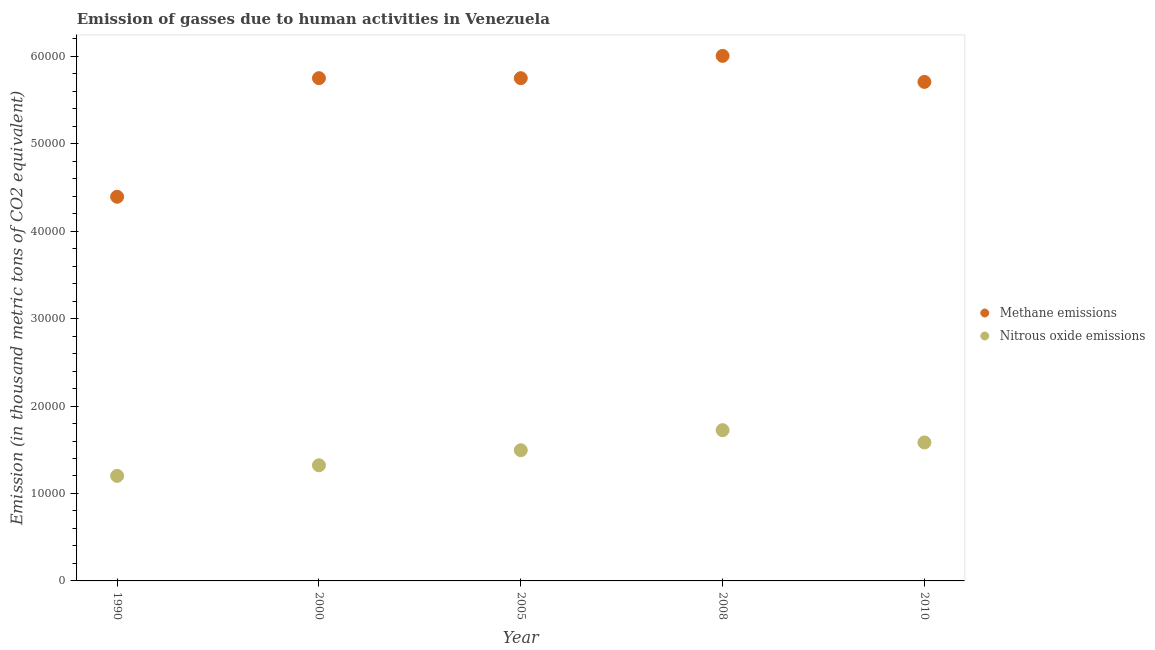What is the amount of methane emissions in 2008?
Ensure brevity in your answer.  6.00e+04. Across all years, what is the maximum amount of nitrous oxide emissions?
Ensure brevity in your answer.  1.72e+04. Across all years, what is the minimum amount of methane emissions?
Your answer should be very brief. 4.39e+04. In which year was the amount of nitrous oxide emissions minimum?
Ensure brevity in your answer.  1990. What is the total amount of methane emissions in the graph?
Make the answer very short. 2.76e+05. What is the difference between the amount of methane emissions in 2008 and that in 2010?
Ensure brevity in your answer.  2976.3. What is the difference between the amount of methane emissions in 2008 and the amount of nitrous oxide emissions in 2005?
Ensure brevity in your answer.  4.51e+04. What is the average amount of methane emissions per year?
Your response must be concise. 5.52e+04. In the year 2008, what is the difference between the amount of nitrous oxide emissions and amount of methane emissions?
Your answer should be compact. -4.28e+04. What is the ratio of the amount of methane emissions in 2000 to that in 2010?
Offer a terse response. 1.01. Is the difference between the amount of methane emissions in 2008 and 2010 greater than the difference between the amount of nitrous oxide emissions in 2008 and 2010?
Your answer should be very brief. Yes. What is the difference between the highest and the second highest amount of nitrous oxide emissions?
Ensure brevity in your answer.  1406.5. What is the difference between the highest and the lowest amount of nitrous oxide emissions?
Provide a succinct answer. 5224.6. In how many years, is the amount of methane emissions greater than the average amount of methane emissions taken over all years?
Keep it short and to the point. 4. Is the sum of the amount of methane emissions in 1990 and 2000 greater than the maximum amount of nitrous oxide emissions across all years?
Keep it short and to the point. Yes. Does the amount of nitrous oxide emissions monotonically increase over the years?
Your answer should be compact. No. How many dotlines are there?
Provide a succinct answer. 2. How many years are there in the graph?
Offer a terse response. 5. What is the difference between two consecutive major ticks on the Y-axis?
Your answer should be very brief. 10000. Are the values on the major ticks of Y-axis written in scientific E-notation?
Your response must be concise. No. Does the graph contain grids?
Your response must be concise. No. Where does the legend appear in the graph?
Keep it short and to the point. Center right. What is the title of the graph?
Ensure brevity in your answer.  Emission of gasses due to human activities in Venezuela. Does "GDP per capita" appear as one of the legend labels in the graph?
Your response must be concise. No. What is the label or title of the X-axis?
Your answer should be very brief. Year. What is the label or title of the Y-axis?
Your response must be concise. Emission (in thousand metric tons of CO2 equivalent). What is the Emission (in thousand metric tons of CO2 equivalent) in Methane emissions in 1990?
Ensure brevity in your answer.  4.39e+04. What is the Emission (in thousand metric tons of CO2 equivalent) of Nitrous oxide emissions in 1990?
Provide a short and direct response. 1.20e+04. What is the Emission (in thousand metric tons of CO2 equivalent) of Methane emissions in 2000?
Give a very brief answer. 5.75e+04. What is the Emission (in thousand metric tons of CO2 equivalent) in Nitrous oxide emissions in 2000?
Ensure brevity in your answer.  1.32e+04. What is the Emission (in thousand metric tons of CO2 equivalent) in Methane emissions in 2005?
Ensure brevity in your answer.  5.75e+04. What is the Emission (in thousand metric tons of CO2 equivalent) in Nitrous oxide emissions in 2005?
Provide a short and direct response. 1.49e+04. What is the Emission (in thousand metric tons of CO2 equivalent) in Methane emissions in 2008?
Your answer should be compact. 6.00e+04. What is the Emission (in thousand metric tons of CO2 equivalent) of Nitrous oxide emissions in 2008?
Your answer should be very brief. 1.72e+04. What is the Emission (in thousand metric tons of CO2 equivalent) of Methane emissions in 2010?
Your answer should be compact. 5.71e+04. What is the Emission (in thousand metric tons of CO2 equivalent) of Nitrous oxide emissions in 2010?
Give a very brief answer. 1.58e+04. Across all years, what is the maximum Emission (in thousand metric tons of CO2 equivalent) of Methane emissions?
Give a very brief answer. 6.00e+04. Across all years, what is the maximum Emission (in thousand metric tons of CO2 equivalent) of Nitrous oxide emissions?
Make the answer very short. 1.72e+04. Across all years, what is the minimum Emission (in thousand metric tons of CO2 equivalent) of Methane emissions?
Your response must be concise. 4.39e+04. Across all years, what is the minimum Emission (in thousand metric tons of CO2 equivalent) of Nitrous oxide emissions?
Make the answer very short. 1.20e+04. What is the total Emission (in thousand metric tons of CO2 equivalent) of Methane emissions in the graph?
Give a very brief answer. 2.76e+05. What is the total Emission (in thousand metric tons of CO2 equivalent) of Nitrous oxide emissions in the graph?
Make the answer very short. 7.33e+04. What is the difference between the Emission (in thousand metric tons of CO2 equivalent) of Methane emissions in 1990 and that in 2000?
Provide a succinct answer. -1.36e+04. What is the difference between the Emission (in thousand metric tons of CO2 equivalent) in Nitrous oxide emissions in 1990 and that in 2000?
Offer a terse response. -1205.8. What is the difference between the Emission (in thousand metric tons of CO2 equivalent) in Methane emissions in 1990 and that in 2005?
Ensure brevity in your answer.  -1.36e+04. What is the difference between the Emission (in thousand metric tons of CO2 equivalent) in Nitrous oxide emissions in 1990 and that in 2005?
Offer a very short reply. -2931.2. What is the difference between the Emission (in thousand metric tons of CO2 equivalent) in Methane emissions in 1990 and that in 2008?
Make the answer very short. -1.61e+04. What is the difference between the Emission (in thousand metric tons of CO2 equivalent) of Nitrous oxide emissions in 1990 and that in 2008?
Give a very brief answer. -5224.6. What is the difference between the Emission (in thousand metric tons of CO2 equivalent) in Methane emissions in 1990 and that in 2010?
Your answer should be very brief. -1.31e+04. What is the difference between the Emission (in thousand metric tons of CO2 equivalent) in Nitrous oxide emissions in 1990 and that in 2010?
Offer a terse response. -3818.1. What is the difference between the Emission (in thousand metric tons of CO2 equivalent) of Nitrous oxide emissions in 2000 and that in 2005?
Provide a succinct answer. -1725.4. What is the difference between the Emission (in thousand metric tons of CO2 equivalent) in Methane emissions in 2000 and that in 2008?
Your response must be concise. -2550.4. What is the difference between the Emission (in thousand metric tons of CO2 equivalent) in Nitrous oxide emissions in 2000 and that in 2008?
Give a very brief answer. -4018.8. What is the difference between the Emission (in thousand metric tons of CO2 equivalent) in Methane emissions in 2000 and that in 2010?
Your answer should be very brief. 425.9. What is the difference between the Emission (in thousand metric tons of CO2 equivalent) of Nitrous oxide emissions in 2000 and that in 2010?
Offer a very short reply. -2612.3. What is the difference between the Emission (in thousand metric tons of CO2 equivalent) of Methane emissions in 2005 and that in 2008?
Give a very brief answer. -2551.2. What is the difference between the Emission (in thousand metric tons of CO2 equivalent) in Nitrous oxide emissions in 2005 and that in 2008?
Make the answer very short. -2293.4. What is the difference between the Emission (in thousand metric tons of CO2 equivalent) of Methane emissions in 2005 and that in 2010?
Keep it short and to the point. 425.1. What is the difference between the Emission (in thousand metric tons of CO2 equivalent) in Nitrous oxide emissions in 2005 and that in 2010?
Offer a terse response. -886.9. What is the difference between the Emission (in thousand metric tons of CO2 equivalent) in Methane emissions in 2008 and that in 2010?
Offer a terse response. 2976.3. What is the difference between the Emission (in thousand metric tons of CO2 equivalent) of Nitrous oxide emissions in 2008 and that in 2010?
Your answer should be compact. 1406.5. What is the difference between the Emission (in thousand metric tons of CO2 equivalent) in Methane emissions in 1990 and the Emission (in thousand metric tons of CO2 equivalent) in Nitrous oxide emissions in 2000?
Make the answer very short. 3.07e+04. What is the difference between the Emission (in thousand metric tons of CO2 equivalent) in Methane emissions in 1990 and the Emission (in thousand metric tons of CO2 equivalent) in Nitrous oxide emissions in 2005?
Provide a succinct answer. 2.90e+04. What is the difference between the Emission (in thousand metric tons of CO2 equivalent) of Methane emissions in 1990 and the Emission (in thousand metric tons of CO2 equivalent) of Nitrous oxide emissions in 2008?
Offer a terse response. 2.67e+04. What is the difference between the Emission (in thousand metric tons of CO2 equivalent) of Methane emissions in 1990 and the Emission (in thousand metric tons of CO2 equivalent) of Nitrous oxide emissions in 2010?
Make the answer very short. 2.81e+04. What is the difference between the Emission (in thousand metric tons of CO2 equivalent) of Methane emissions in 2000 and the Emission (in thousand metric tons of CO2 equivalent) of Nitrous oxide emissions in 2005?
Offer a very short reply. 4.25e+04. What is the difference between the Emission (in thousand metric tons of CO2 equivalent) of Methane emissions in 2000 and the Emission (in thousand metric tons of CO2 equivalent) of Nitrous oxide emissions in 2008?
Your response must be concise. 4.03e+04. What is the difference between the Emission (in thousand metric tons of CO2 equivalent) of Methane emissions in 2000 and the Emission (in thousand metric tons of CO2 equivalent) of Nitrous oxide emissions in 2010?
Give a very brief answer. 4.17e+04. What is the difference between the Emission (in thousand metric tons of CO2 equivalent) in Methane emissions in 2005 and the Emission (in thousand metric tons of CO2 equivalent) in Nitrous oxide emissions in 2008?
Provide a succinct answer. 4.03e+04. What is the difference between the Emission (in thousand metric tons of CO2 equivalent) in Methane emissions in 2005 and the Emission (in thousand metric tons of CO2 equivalent) in Nitrous oxide emissions in 2010?
Make the answer very short. 4.17e+04. What is the difference between the Emission (in thousand metric tons of CO2 equivalent) in Methane emissions in 2008 and the Emission (in thousand metric tons of CO2 equivalent) in Nitrous oxide emissions in 2010?
Your response must be concise. 4.42e+04. What is the average Emission (in thousand metric tons of CO2 equivalent) of Methane emissions per year?
Keep it short and to the point. 5.52e+04. What is the average Emission (in thousand metric tons of CO2 equivalent) of Nitrous oxide emissions per year?
Provide a short and direct response. 1.47e+04. In the year 1990, what is the difference between the Emission (in thousand metric tons of CO2 equivalent) in Methane emissions and Emission (in thousand metric tons of CO2 equivalent) in Nitrous oxide emissions?
Your answer should be compact. 3.19e+04. In the year 2000, what is the difference between the Emission (in thousand metric tons of CO2 equivalent) in Methane emissions and Emission (in thousand metric tons of CO2 equivalent) in Nitrous oxide emissions?
Keep it short and to the point. 4.43e+04. In the year 2005, what is the difference between the Emission (in thousand metric tons of CO2 equivalent) of Methane emissions and Emission (in thousand metric tons of CO2 equivalent) of Nitrous oxide emissions?
Your response must be concise. 4.25e+04. In the year 2008, what is the difference between the Emission (in thousand metric tons of CO2 equivalent) in Methane emissions and Emission (in thousand metric tons of CO2 equivalent) in Nitrous oxide emissions?
Provide a succinct answer. 4.28e+04. In the year 2010, what is the difference between the Emission (in thousand metric tons of CO2 equivalent) in Methane emissions and Emission (in thousand metric tons of CO2 equivalent) in Nitrous oxide emissions?
Provide a succinct answer. 4.12e+04. What is the ratio of the Emission (in thousand metric tons of CO2 equivalent) in Methane emissions in 1990 to that in 2000?
Offer a very short reply. 0.76. What is the ratio of the Emission (in thousand metric tons of CO2 equivalent) in Nitrous oxide emissions in 1990 to that in 2000?
Provide a succinct answer. 0.91. What is the ratio of the Emission (in thousand metric tons of CO2 equivalent) in Methane emissions in 1990 to that in 2005?
Keep it short and to the point. 0.76. What is the ratio of the Emission (in thousand metric tons of CO2 equivalent) in Nitrous oxide emissions in 1990 to that in 2005?
Make the answer very short. 0.8. What is the ratio of the Emission (in thousand metric tons of CO2 equivalent) in Methane emissions in 1990 to that in 2008?
Provide a short and direct response. 0.73. What is the ratio of the Emission (in thousand metric tons of CO2 equivalent) in Nitrous oxide emissions in 1990 to that in 2008?
Ensure brevity in your answer.  0.7. What is the ratio of the Emission (in thousand metric tons of CO2 equivalent) of Methane emissions in 1990 to that in 2010?
Your answer should be compact. 0.77. What is the ratio of the Emission (in thousand metric tons of CO2 equivalent) in Nitrous oxide emissions in 1990 to that in 2010?
Provide a short and direct response. 0.76. What is the ratio of the Emission (in thousand metric tons of CO2 equivalent) in Nitrous oxide emissions in 2000 to that in 2005?
Provide a short and direct response. 0.88. What is the ratio of the Emission (in thousand metric tons of CO2 equivalent) of Methane emissions in 2000 to that in 2008?
Your response must be concise. 0.96. What is the ratio of the Emission (in thousand metric tons of CO2 equivalent) of Nitrous oxide emissions in 2000 to that in 2008?
Provide a succinct answer. 0.77. What is the ratio of the Emission (in thousand metric tons of CO2 equivalent) in Methane emissions in 2000 to that in 2010?
Ensure brevity in your answer.  1.01. What is the ratio of the Emission (in thousand metric tons of CO2 equivalent) in Nitrous oxide emissions in 2000 to that in 2010?
Provide a short and direct response. 0.83. What is the ratio of the Emission (in thousand metric tons of CO2 equivalent) of Methane emissions in 2005 to that in 2008?
Your answer should be very brief. 0.96. What is the ratio of the Emission (in thousand metric tons of CO2 equivalent) of Nitrous oxide emissions in 2005 to that in 2008?
Ensure brevity in your answer.  0.87. What is the ratio of the Emission (in thousand metric tons of CO2 equivalent) of Methane emissions in 2005 to that in 2010?
Offer a terse response. 1.01. What is the ratio of the Emission (in thousand metric tons of CO2 equivalent) of Nitrous oxide emissions in 2005 to that in 2010?
Offer a terse response. 0.94. What is the ratio of the Emission (in thousand metric tons of CO2 equivalent) in Methane emissions in 2008 to that in 2010?
Your answer should be very brief. 1.05. What is the ratio of the Emission (in thousand metric tons of CO2 equivalent) in Nitrous oxide emissions in 2008 to that in 2010?
Give a very brief answer. 1.09. What is the difference between the highest and the second highest Emission (in thousand metric tons of CO2 equivalent) of Methane emissions?
Ensure brevity in your answer.  2550.4. What is the difference between the highest and the second highest Emission (in thousand metric tons of CO2 equivalent) in Nitrous oxide emissions?
Keep it short and to the point. 1406.5. What is the difference between the highest and the lowest Emission (in thousand metric tons of CO2 equivalent) of Methane emissions?
Your answer should be very brief. 1.61e+04. What is the difference between the highest and the lowest Emission (in thousand metric tons of CO2 equivalent) of Nitrous oxide emissions?
Offer a very short reply. 5224.6. 